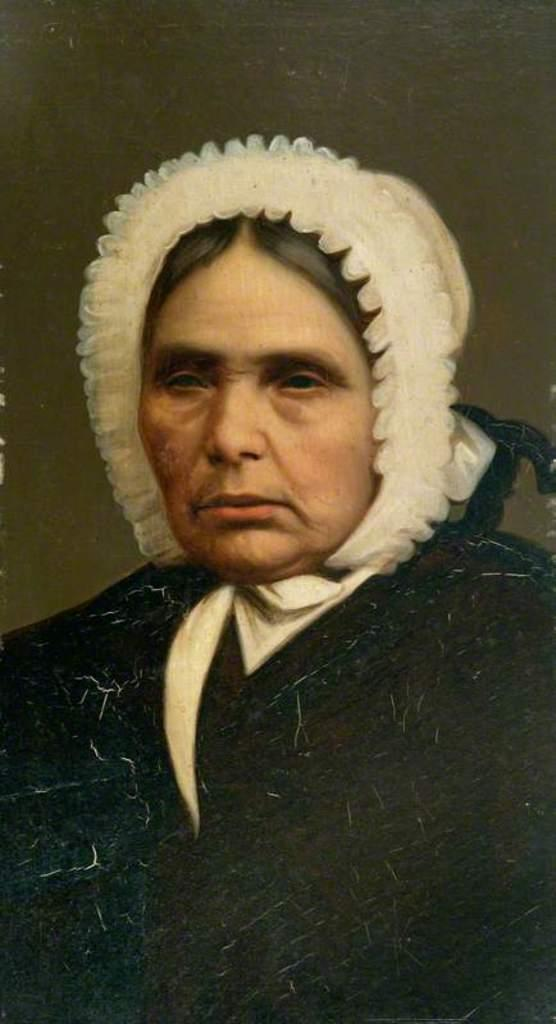What is the main subject of the image? There is a woman in the image. What is the woman wearing on her upper body? The woman is wearing a black sweater. What type of headwear is the woman wearing? The woman is wearing a white cap. What type of medical advice is the woman providing in the image? There is no indication in the image that the woman is providing medical advice or acting as a doctor. 